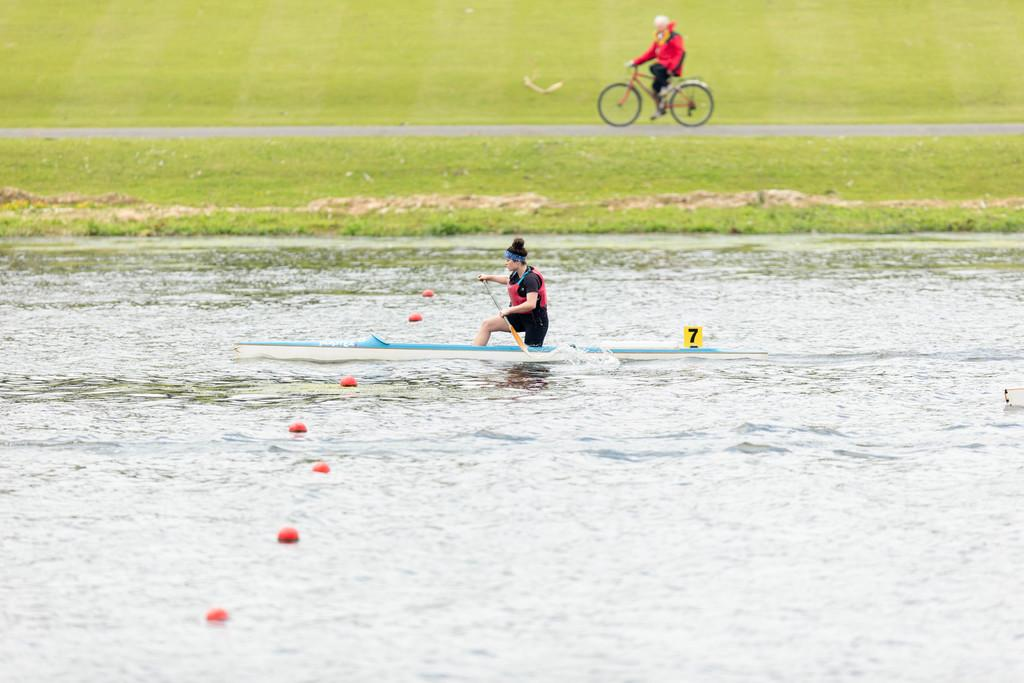What is the man in the image doing? The man is riding a small boat in the river water. What can be seen in the background of the image? There is a grass farm and an old man in the background. What is the old man wearing? The old man is wearing a red jacket. What is the old man doing in the image? The old man is riding a bicycle. What type of toothpaste is the man using while riding the boat in the image? There is no toothpaste present in the image, as the man is riding a boat in the river water. 